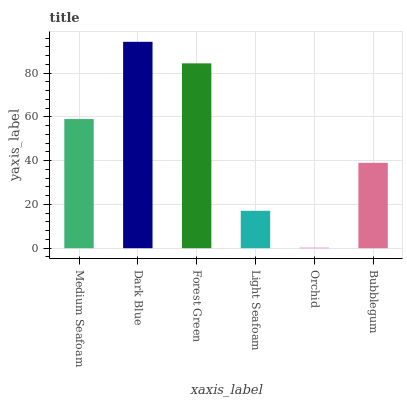Is Forest Green the minimum?
Answer yes or no. No. Is Forest Green the maximum?
Answer yes or no. No. Is Dark Blue greater than Forest Green?
Answer yes or no. Yes. Is Forest Green less than Dark Blue?
Answer yes or no. Yes. Is Forest Green greater than Dark Blue?
Answer yes or no. No. Is Dark Blue less than Forest Green?
Answer yes or no. No. Is Medium Seafoam the high median?
Answer yes or no. Yes. Is Bubblegum the low median?
Answer yes or no. Yes. Is Bubblegum the high median?
Answer yes or no. No. Is Light Seafoam the low median?
Answer yes or no. No. 